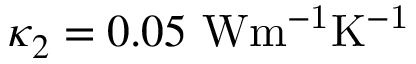<formula> <loc_0><loc_0><loc_500><loc_500>\kappa _ { 2 } = 0 . 0 5 { W m ^ { - 1 } K ^ { - 1 } }</formula> 